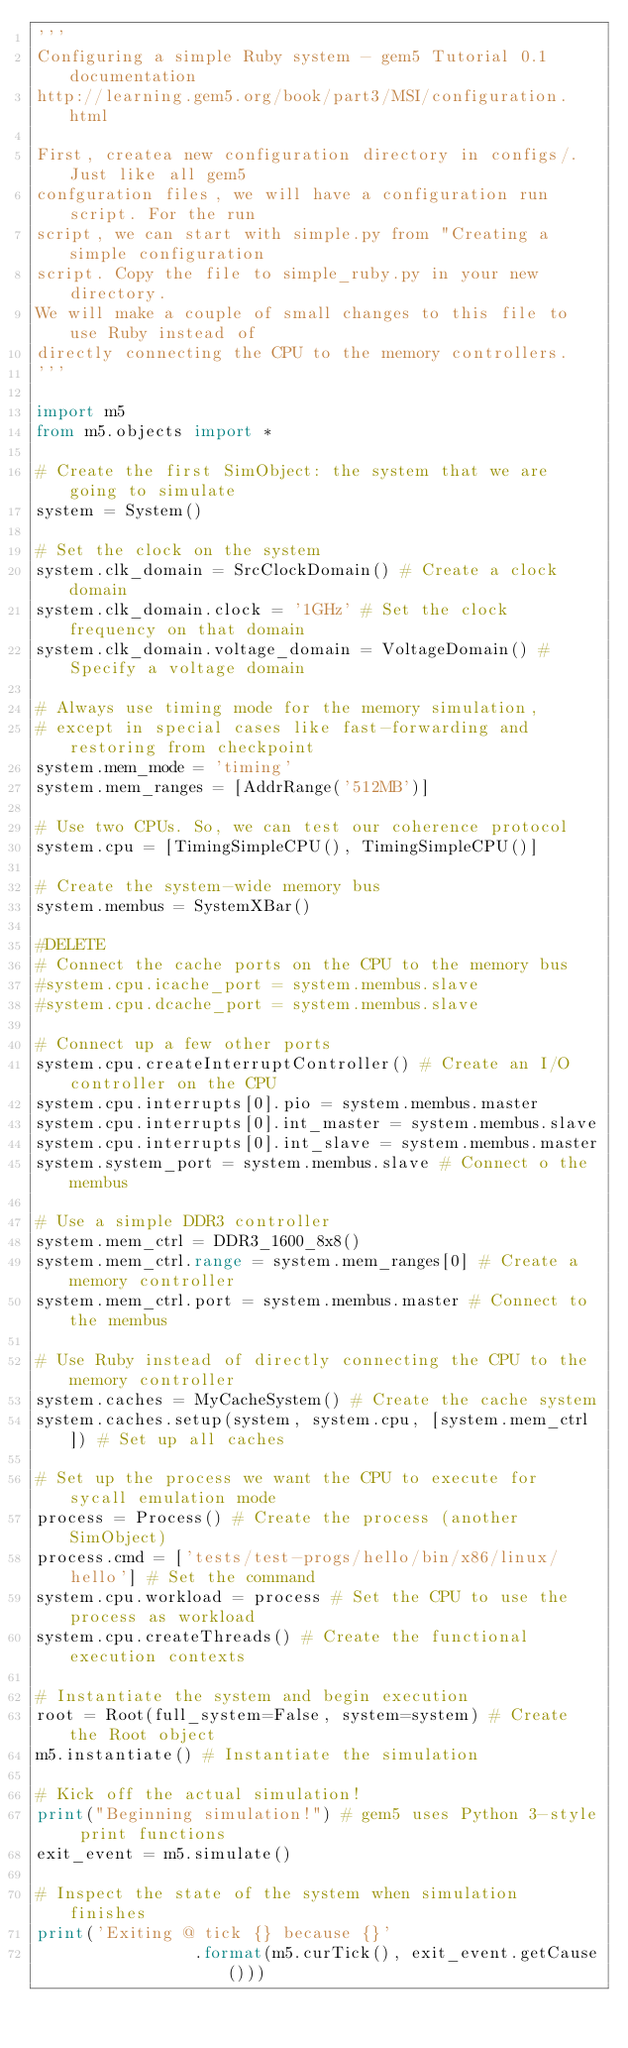<code> <loc_0><loc_0><loc_500><loc_500><_Python_>'''
Configuring a simple Ruby system - gem5 Tutorial 0.1 documentation
http://learning.gem5.org/book/part3/MSI/configuration.html

First, createa new configuration directory in configs/. Just like all gem5
confguration files, we will have a configuration run script. For the run
script, we can start with simple.py from "Creating a simple configuration
script. Copy the file to simple_ruby.py in your new directory.
We will make a couple of small changes to this file to use Ruby instead of
directly connecting the CPU to the memory controllers.
'''

import m5
from m5.objects import *

# Create the first SimObject: the system that we are going to simulate
system = System()

# Set the clock on the system
system.clk_domain = SrcClockDomain() # Create a clock domain
system.clk_domain.clock = '1GHz' # Set the clock frequency on that domain
system.clk_domain.voltage_domain = VoltageDomain() # Specify a voltage domain

# Always use timing mode for the memory simulation,
# except in special cases like fast-forwarding and restoring from checkpoint
system.mem_mode = 'timing'
system.mem_ranges = [AddrRange('512MB')]

# Use two CPUs. So, we can test our coherence protocol
system.cpu = [TimingSimpleCPU(), TimingSimpleCPU()]

# Create the system-wide memory bus
system.membus = SystemXBar()

#DELETE
# Connect the cache ports on the CPU to the memory bus
#system.cpu.icache_port = system.membus.slave
#system.cpu.dcache_port = system.membus.slave

# Connect up a few other ports
system.cpu.createInterruptController() # Create an I/O controller on the CPU
system.cpu.interrupts[0].pio = system.membus.master
system.cpu.interrupts[0].int_master = system.membus.slave
system.cpu.interrupts[0].int_slave = system.membus.master
system.system_port = system.membus.slave # Connect o the membus

# Use a simple DDR3 controller
system.mem_ctrl = DDR3_1600_8x8()
system.mem_ctrl.range = system.mem_ranges[0] # Create a memory controller
system.mem_ctrl.port = system.membus.master # Connect to the membus

# Use Ruby instead of directly connecting the CPU to the memory controller
system.caches = MyCacheSystem() # Create the cache system
system.caches.setup(system, system.cpu, [system.mem_ctrl]) # Set up all caches

# Set up the process we want the CPU to execute for sycall emulation mode
process = Process() # Create the process (another SimObject)
process.cmd = ['tests/test-progs/hello/bin/x86/linux/hello'] # Set the command
system.cpu.workload = process # Set the CPU to use the process as workload
system.cpu.createThreads() # Create the functional execution contexts

# Instantiate the system and begin execution
root = Root(full_system=False, system=system) # Create the Root object
m5.instantiate() # Instantiate the simulation

# Kick off the actual simulation!
print("Beginning simulation!") # gem5 uses Python 3-style print functions
exit_event = m5.simulate()

# Inspect the state of the system when simulation finishes
print('Exiting @ tick {} because {}'
                .format(m5.curTick(), exit_event.getCause()))

</code> 